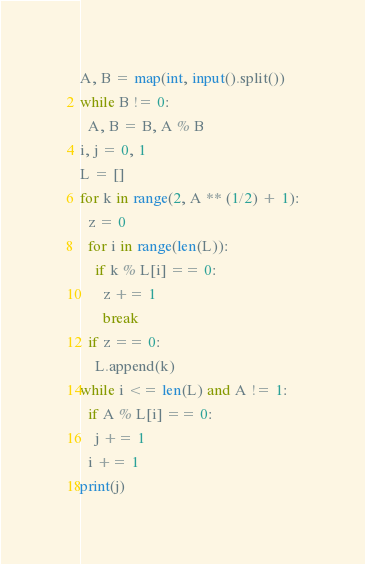Convert code to text. <code><loc_0><loc_0><loc_500><loc_500><_Python_>A, B = map(int, input().split())
while B != 0:
  A, B = B, A % B
i, j = 0, 1
L = []
for k in range(2, A ** (1/2) + 1):
  z = 0
  for i in range(len(L)):
    if k % L[i] == 0:
      z += 1
      break
  if z == 0:
    L.append(k)
while i <= len(L) and A != 1:
  if A % L[i] == 0:
    j += 1
  i += 1
print(j)</code> 